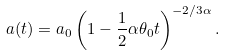<formula> <loc_0><loc_0><loc_500><loc_500>a ( t ) = a _ { 0 } \left ( 1 - \frac { 1 } { 2 } \alpha \theta _ { 0 } t \right ) ^ { - 2 / 3 \alpha } .</formula> 